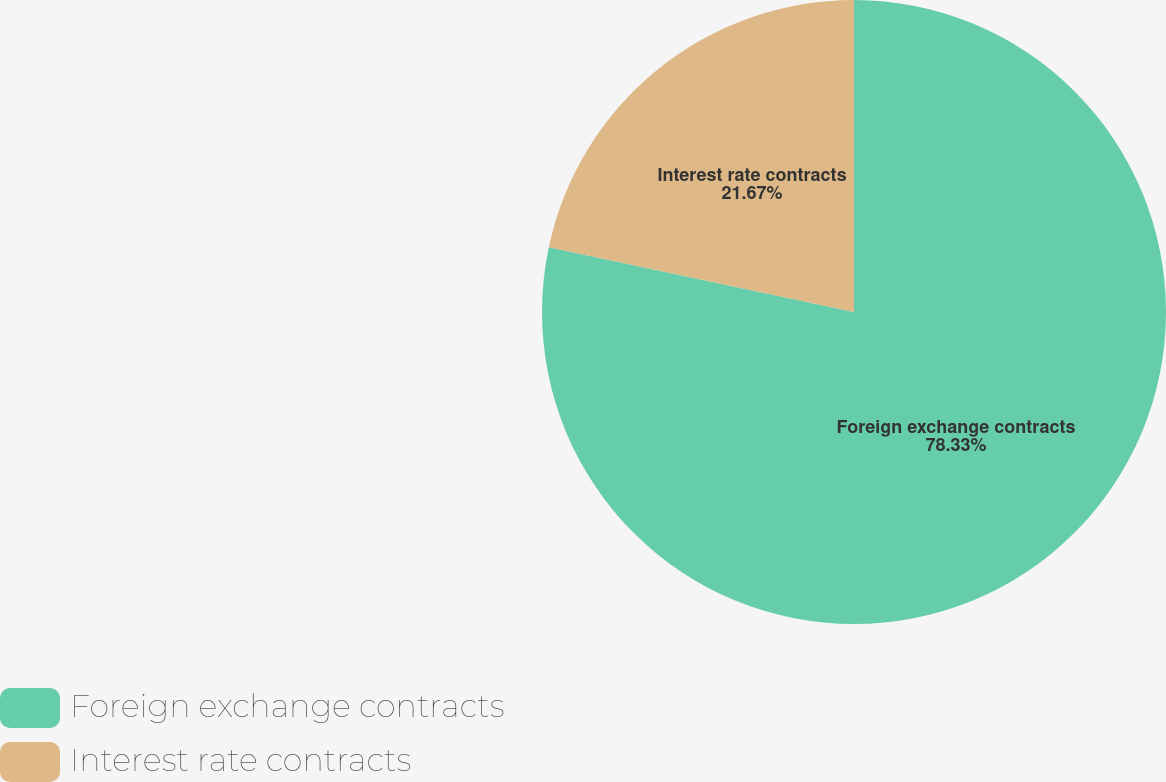<chart> <loc_0><loc_0><loc_500><loc_500><pie_chart><fcel>Foreign exchange contracts<fcel>Interest rate contracts<nl><fcel>78.33%<fcel>21.67%<nl></chart> 